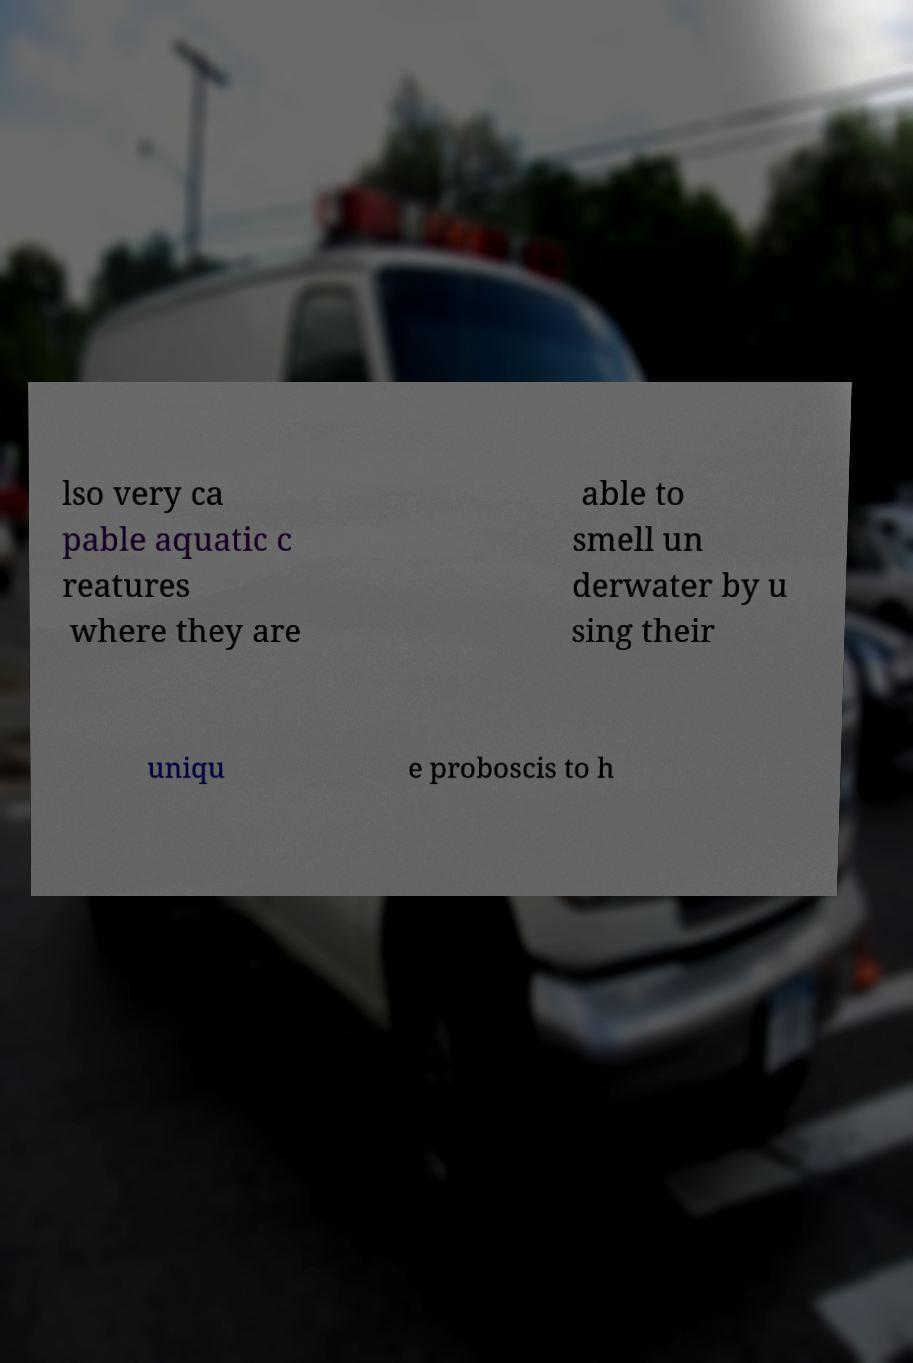Please identify and transcribe the text found in this image. lso very ca pable aquatic c reatures where they are able to smell un derwater by u sing their uniqu e proboscis to h 